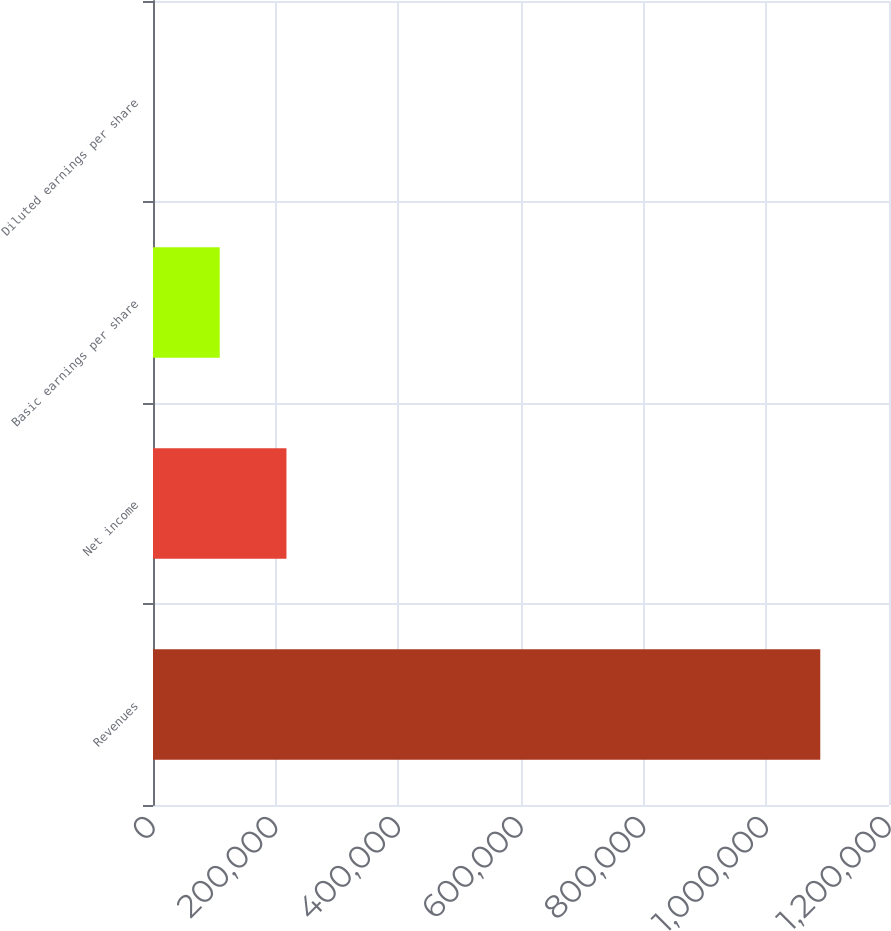<chart> <loc_0><loc_0><loc_500><loc_500><bar_chart><fcel>Revenues<fcel>Net income<fcel>Basic earnings per share<fcel>Diluted earnings per share<nl><fcel>1.08795e+06<fcel>217590<fcel>108796<fcel>1.33<nl></chart> 